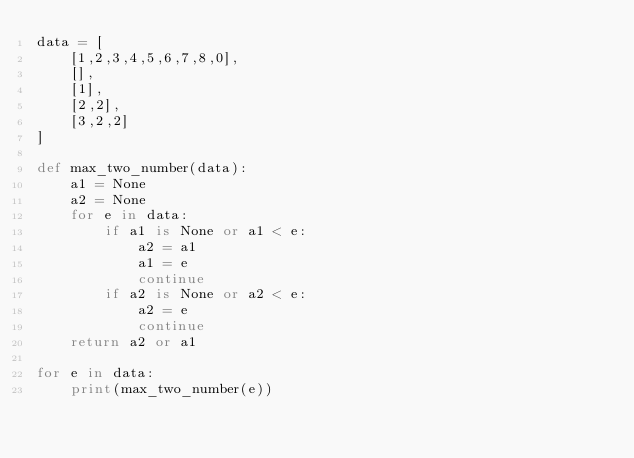<code> <loc_0><loc_0><loc_500><loc_500><_Python_>data = [
    [1,2,3,4,5,6,7,8,0],
    [],
    [1],
    [2,2],
    [3,2,2]
]

def max_two_number(data):
    a1 = None
    a2 = None
    for e in data:
        if a1 is None or a1 < e:
            a2 = a1
            a1 = e
            continue
        if a2 is None or a2 < e:
            a2 = e
            continue
    return a2 or a1

for e in data:
    print(max_two_number(e))

</code> 